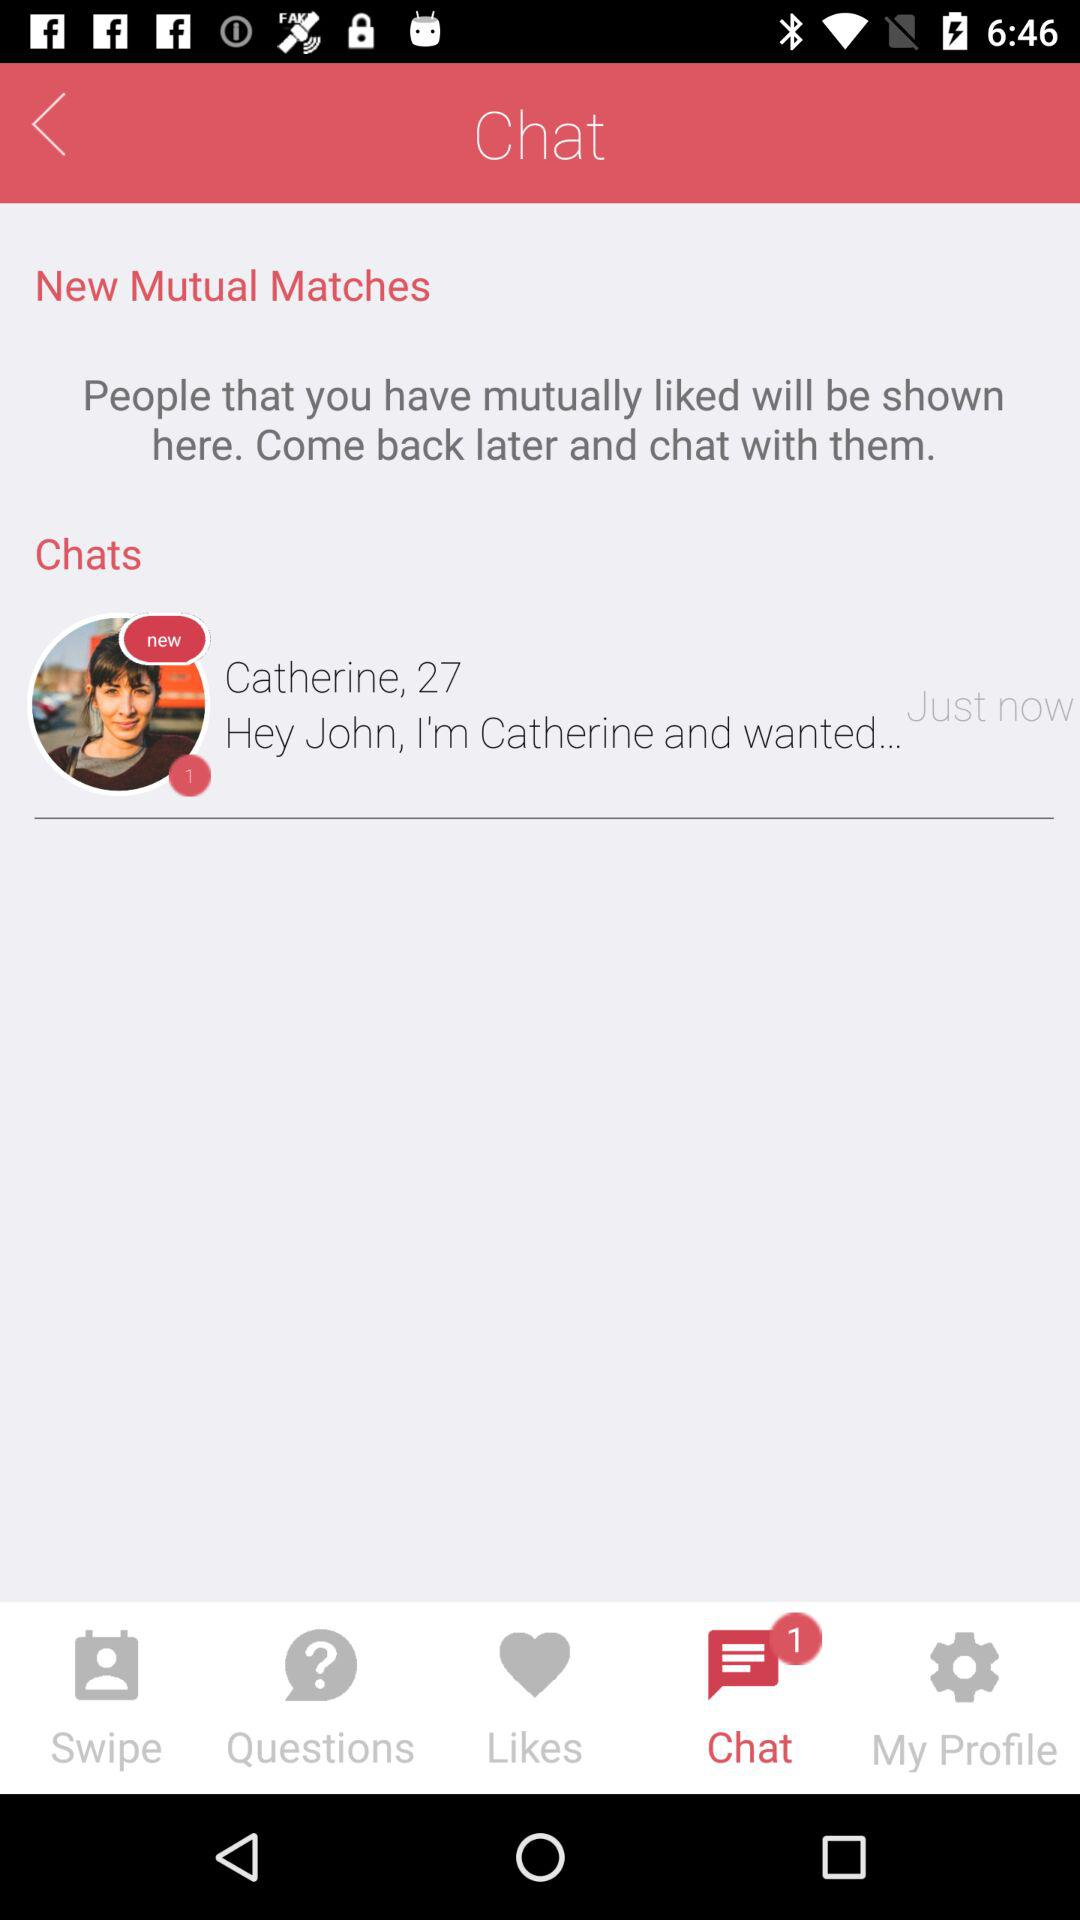How many likes are there?
When the provided information is insufficient, respond with <no answer>. <no answer> 